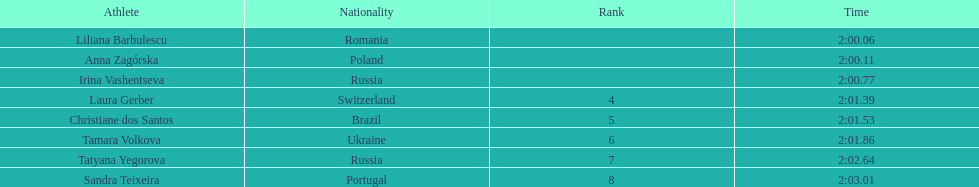How many runners finished with their time below 2:01? 3. 